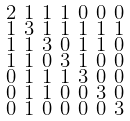Convert formula to latex. <formula><loc_0><loc_0><loc_500><loc_500>\begin{smallmatrix} 2 & 1 & 1 & 1 & 0 & 0 & 0 \\ 1 & 3 & 1 & 1 & 1 & 1 & 1 \\ 1 & 1 & 3 & 0 & 1 & 1 & 0 \\ 1 & 1 & 0 & 3 & 1 & 0 & 0 \\ 0 & 1 & 1 & 1 & 3 & 0 & 0 \\ 0 & 1 & 1 & 0 & 0 & 3 & 0 \\ 0 & 1 & 0 & 0 & 0 & 0 & 3 \end{smallmatrix}</formula> 